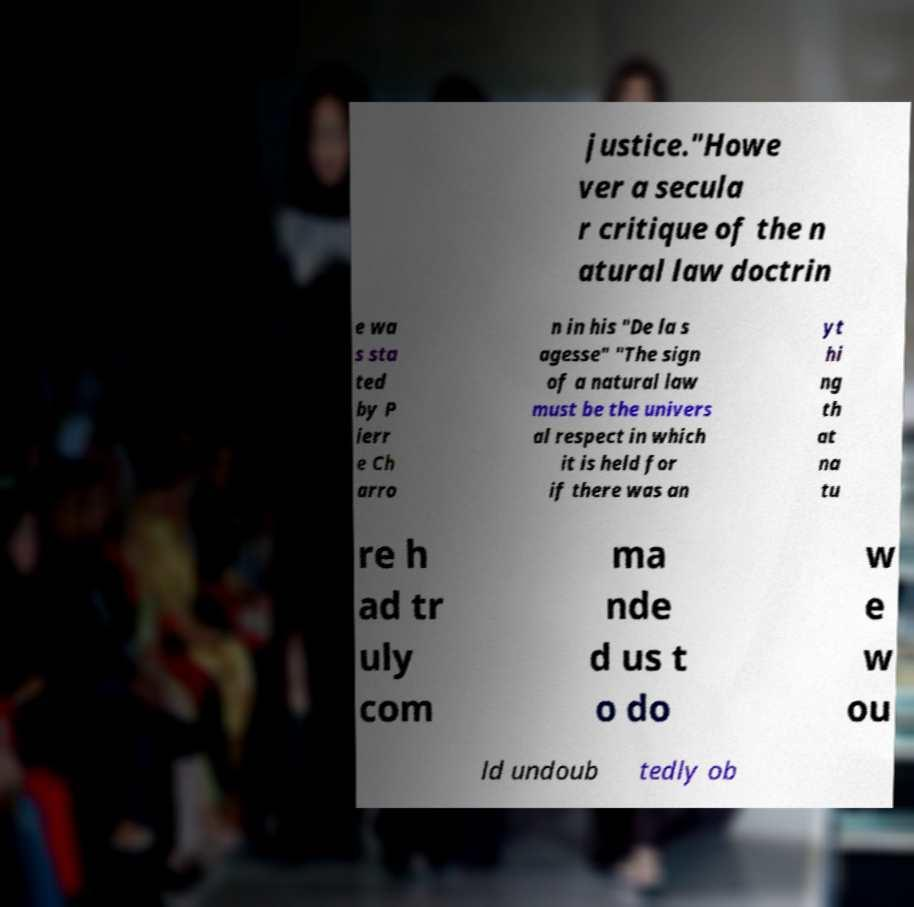Can you read and provide the text displayed in the image?This photo seems to have some interesting text. Can you extract and type it out for me? justice."Howe ver a secula r critique of the n atural law doctrin e wa s sta ted by P ierr e Ch arro n in his "De la s agesse" "The sign of a natural law must be the univers al respect in which it is held for if there was an yt hi ng th at na tu re h ad tr uly com ma nde d us t o do w e w ou ld undoub tedly ob 